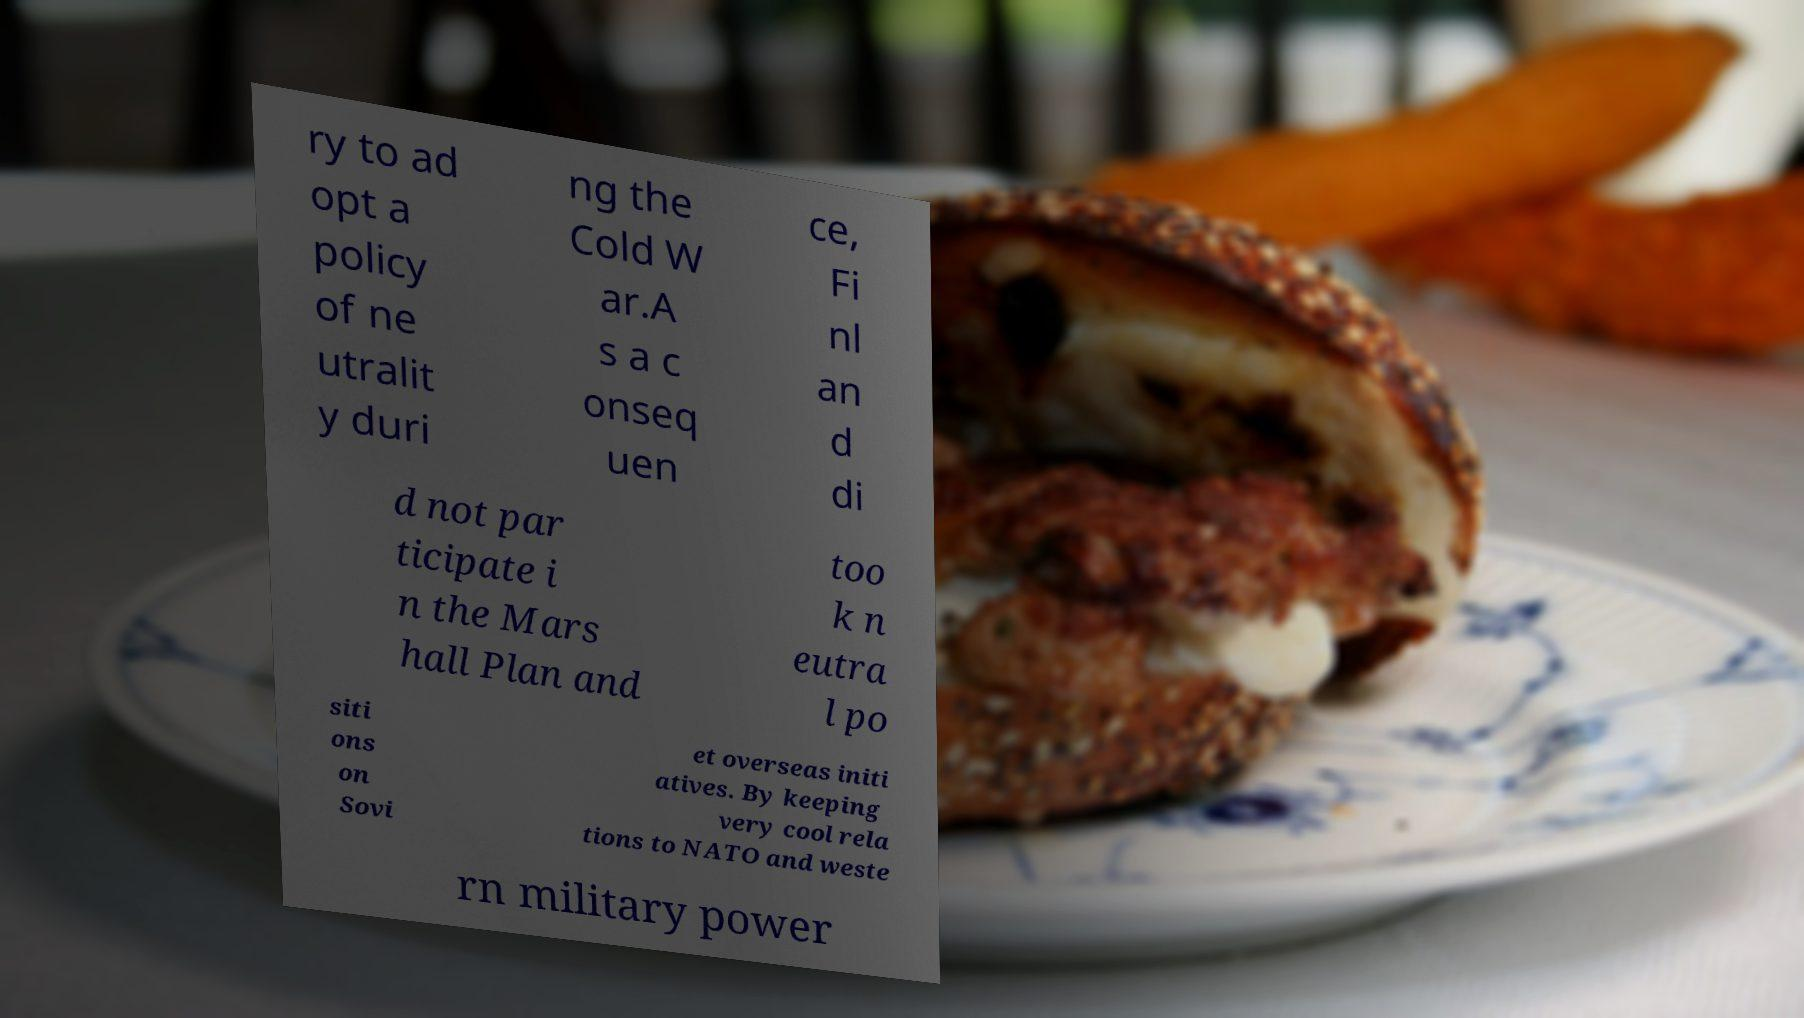Can you read and provide the text displayed in the image?This photo seems to have some interesting text. Can you extract and type it out for me? ry to ad opt a policy of ne utralit y duri ng the Cold W ar.A s a c onseq uen ce, Fi nl an d di d not par ticipate i n the Mars hall Plan and too k n eutra l po siti ons on Sovi et overseas initi atives. By keeping very cool rela tions to NATO and weste rn military power 